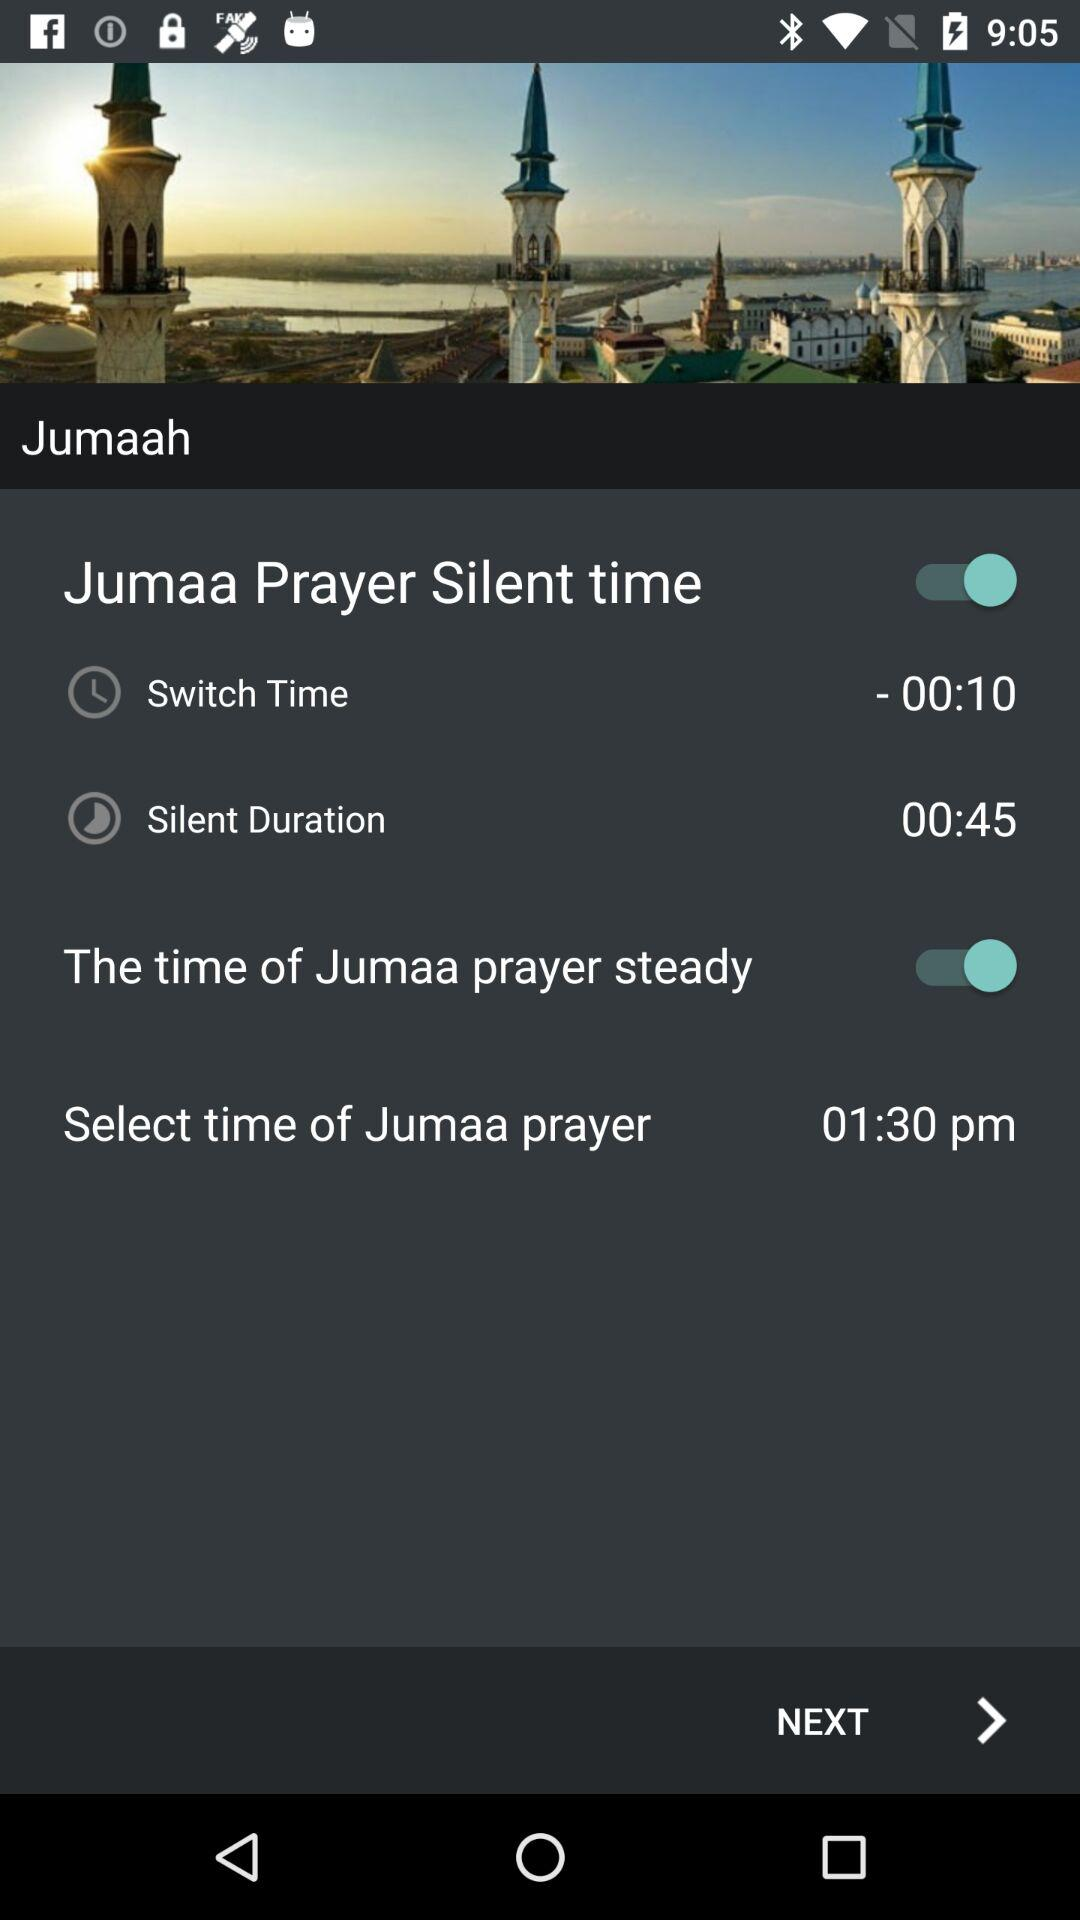What is the silent duration? The silent duration is 45 seconds. 